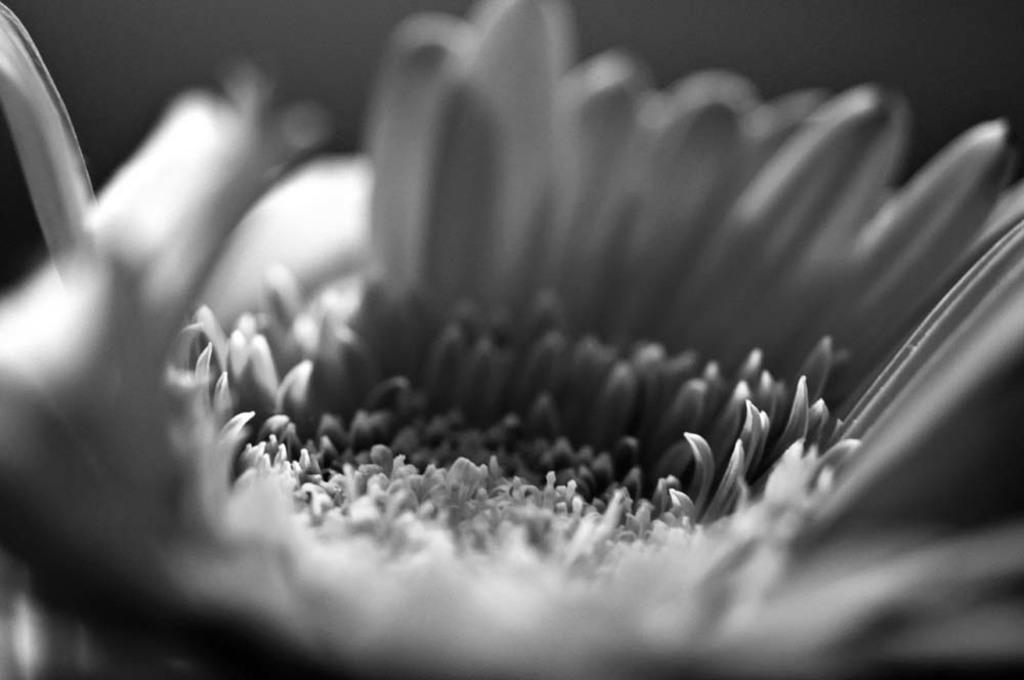What is the main subject of the image? There is a flower in the image. What color scheme is used in the image? The image is black and white in color. Can you tell me how the deer is feeling in the image? There is no deer present in the image, so it is not possible to determine how a deer might be feeling. What color is the flower in the image? The image is black and white in color, so it is not possible to determine the color of the flower. 